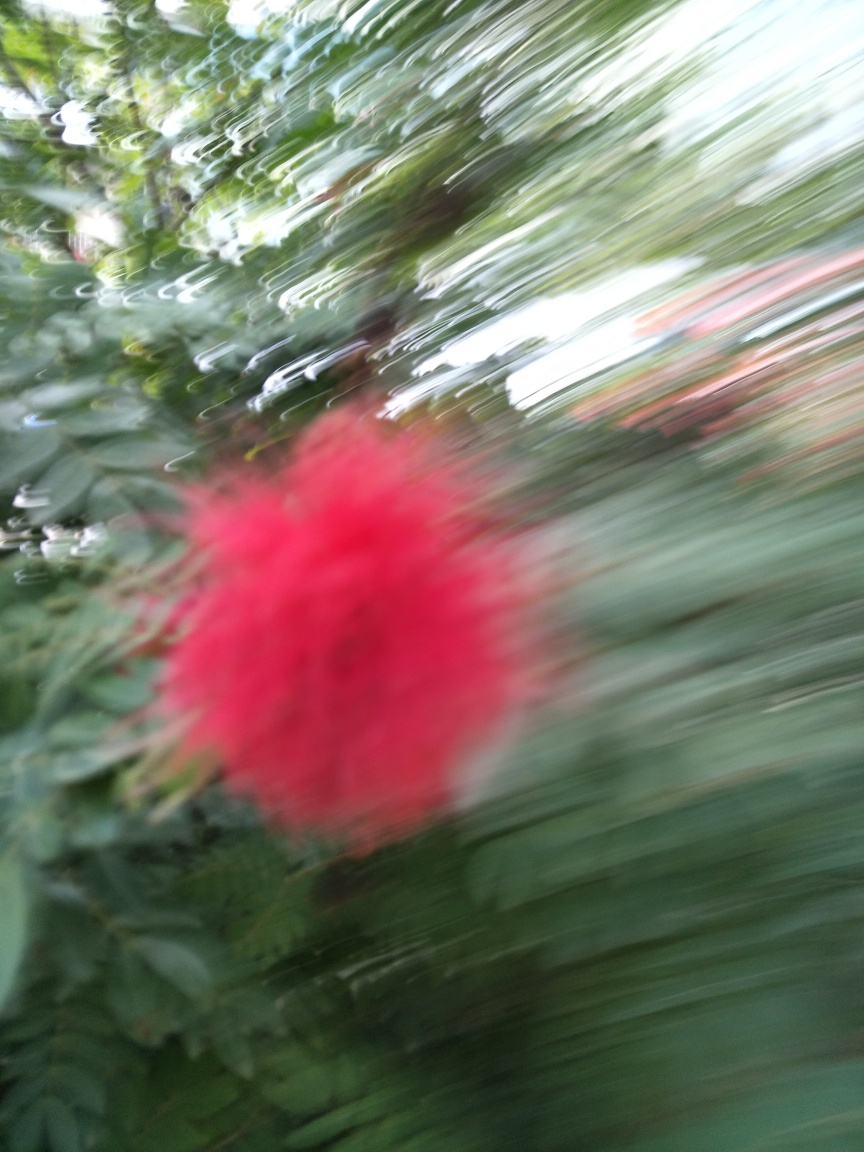Are there any quality issues with this image? Yes, the image appears to be blurred, which suggests motion blur likely due to camera movement during the shot, and this affects the image clarity and detail. 